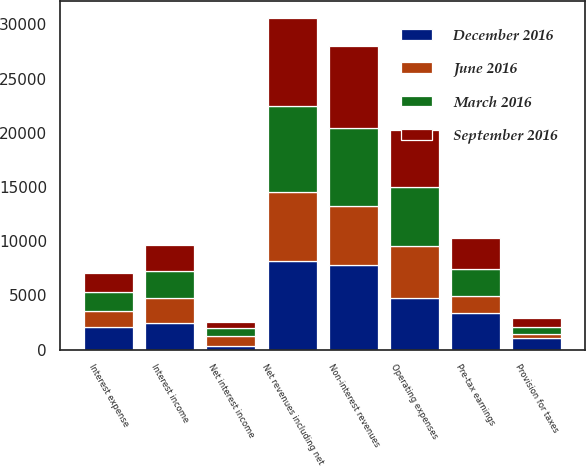<chart> <loc_0><loc_0><loc_500><loc_500><stacked_bar_chart><ecel><fcel>Non-interest revenues<fcel>Interest income<fcel>Interest expense<fcel>Net interest income<fcel>Net revenues including net<fcel>Operating expenses<fcel>Pre-tax earnings<fcel>Provision for taxes<nl><fcel>December 2016<fcel>7834<fcel>2424<fcel>2088<fcel>336<fcel>8170<fcel>4773<fcel>3397<fcel>1050<nl><fcel>September 2016<fcel>7554<fcel>2389<fcel>1775<fcel>614<fcel>8168<fcel>5300<fcel>2868<fcel>774<nl><fcel>March 2016<fcel>7178<fcel>2530<fcel>1776<fcel>754<fcel>7932<fcel>5469<fcel>2463<fcel>641<nl><fcel>June 2016<fcel>5455<fcel>2348<fcel>1465<fcel>883<fcel>6338<fcel>4762<fcel>1576<fcel>441<nl></chart> 